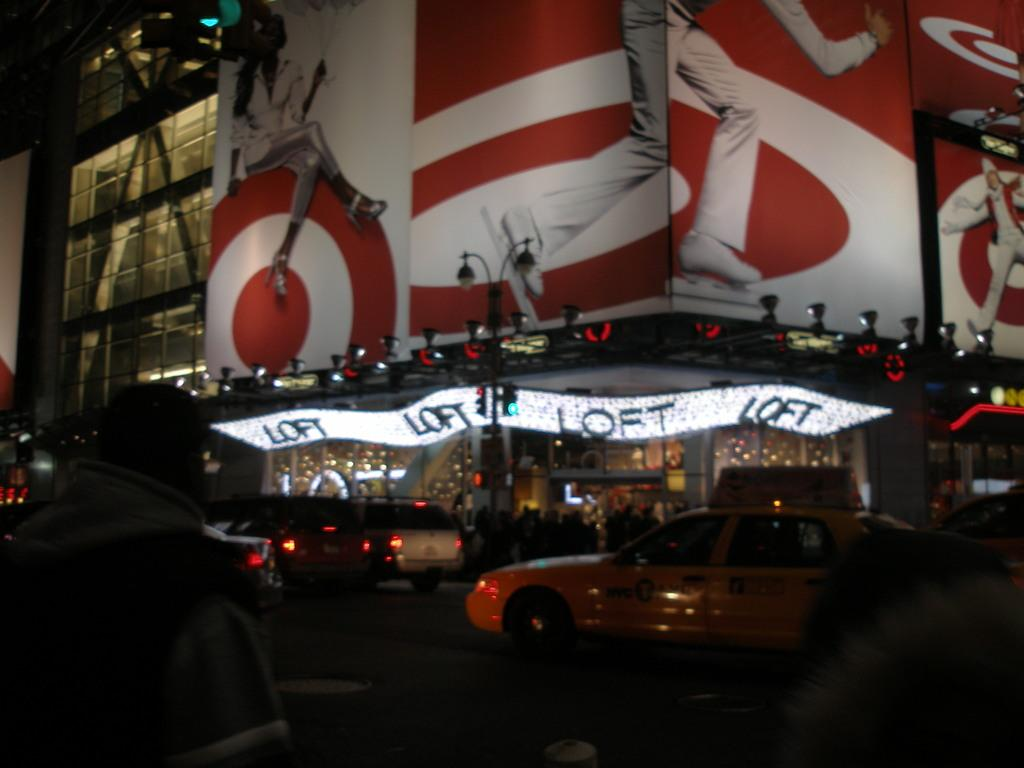<image>
Relay a brief, clear account of the picture shown. a scoreboard with the name loft on it 